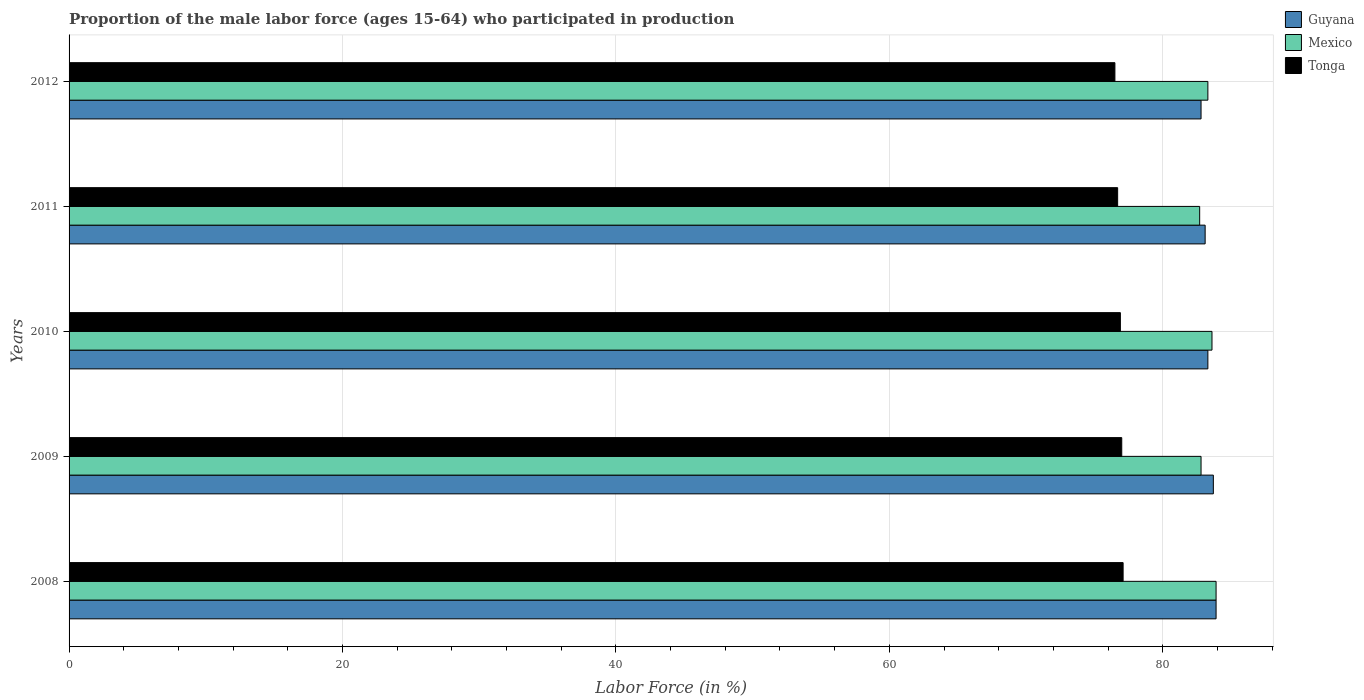How many different coloured bars are there?
Your answer should be compact. 3. How many groups of bars are there?
Provide a short and direct response. 5. Are the number of bars per tick equal to the number of legend labels?
Provide a short and direct response. Yes. Are the number of bars on each tick of the Y-axis equal?
Offer a terse response. Yes. How many bars are there on the 4th tick from the bottom?
Provide a succinct answer. 3. What is the label of the 5th group of bars from the top?
Your response must be concise. 2008. In how many cases, is the number of bars for a given year not equal to the number of legend labels?
Provide a succinct answer. 0. What is the proportion of the male labor force who participated in production in Tonga in 2010?
Offer a terse response. 76.9. Across all years, what is the maximum proportion of the male labor force who participated in production in Tonga?
Give a very brief answer. 77.1. Across all years, what is the minimum proportion of the male labor force who participated in production in Guyana?
Your answer should be very brief. 82.8. In which year was the proportion of the male labor force who participated in production in Mexico maximum?
Your answer should be compact. 2008. In which year was the proportion of the male labor force who participated in production in Tonga minimum?
Ensure brevity in your answer.  2012. What is the total proportion of the male labor force who participated in production in Tonga in the graph?
Give a very brief answer. 384.2. What is the difference between the proportion of the male labor force who participated in production in Mexico in 2011 and that in 2012?
Offer a very short reply. -0.6. What is the average proportion of the male labor force who participated in production in Mexico per year?
Make the answer very short. 83.26. In the year 2009, what is the difference between the proportion of the male labor force who participated in production in Mexico and proportion of the male labor force who participated in production in Guyana?
Ensure brevity in your answer.  -0.9. What is the ratio of the proportion of the male labor force who participated in production in Guyana in 2010 to that in 2011?
Offer a very short reply. 1. Is the difference between the proportion of the male labor force who participated in production in Mexico in 2009 and 2011 greater than the difference between the proportion of the male labor force who participated in production in Guyana in 2009 and 2011?
Your response must be concise. No. What is the difference between the highest and the second highest proportion of the male labor force who participated in production in Tonga?
Ensure brevity in your answer.  0.1. What is the difference between the highest and the lowest proportion of the male labor force who participated in production in Mexico?
Ensure brevity in your answer.  1.2. In how many years, is the proportion of the male labor force who participated in production in Mexico greater than the average proportion of the male labor force who participated in production in Mexico taken over all years?
Offer a very short reply. 3. What does the 3rd bar from the top in 2012 represents?
Ensure brevity in your answer.  Guyana. What does the 1st bar from the bottom in 2012 represents?
Give a very brief answer. Guyana. Are all the bars in the graph horizontal?
Your answer should be compact. Yes. How many years are there in the graph?
Provide a succinct answer. 5. Are the values on the major ticks of X-axis written in scientific E-notation?
Your answer should be compact. No. Does the graph contain any zero values?
Provide a succinct answer. No. Does the graph contain grids?
Your response must be concise. Yes. How many legend labels are there?
Offer a very short reply. 3. How are the legend labels stacked?
Offer a terse response. Vertical. What is the title of the graph?
Offer a very short reply. Proportion of the male labor force (ages 15-64) who participated in production. What is the label or title of the X-axis?
Offer a terse response. Labor Force (in %). What is the label or title of the Y-axis?
Keep it short and to the point. Years. What is the Labor Force (in %) in Guyana in 2008?
Ensure brevity in your answer.  83.9. What is the Labor Force (in %) in Mexico in 2008?
Offer a very short reply. 83.9. What is the Labor Force (in %) of Tonga in 2008?
Your response must be concise. 77.1. What is the Labor Force (in %) in Guyana in 2009?
Give a very brief answer. 83.7. What is the Labor Force (in %) of Mexico in 2009?
Keep it short and to the point. 82.8. What is the Labor Force (in %) of Tonga in 2009?
Keep it short and to the point. 77. What is the Labor Force (in %) of Guyana in 2010?
Keep it short and to the point. 83.3. What is the Labor Force (in %) in Mexico in 2010?
Keep it short and to the point. 83.6. What is the Labor Force (in %) of Tonga in 2010?
Keep it short and to the point. 76.9. What is the Labor Force (in %) in Guyana in 2011?
Offer a very short reply. 83.1. What is the Labor Force (in %) of Mexico in 2011?
Give a very brief answer. 82.7. What is the Labor Force (in %) in Tonga in 2011?
Ensure brevity in your answer.  76.7. What is the Labor Force (in %) in Guyana in 2012?
Your response must be concise. 82.8. What is the Labor Force (in %) of Mexico in 2012?
Offer a terse response. 83.3. What is the Labor Force (in %) in Tonga in 2012?
Give a very brief answer. 76.5. Across all years, what is the maximum Labor Force (in %) of Guyana?
Offer a terse response. 83.9. Across all years, what is the maximum Labor Force (in %) in Mexico?
Give a very brief answer. 83.9. Across all years, what is the maximum Labor Force (in %) of Tonga?
Provide a short and direct response. 77.1. Across all years, what is the minimum Labor Force (in %) in Guyana?
Offer a very short reply. 82.8. Across all years, what is the minimum Labor Force (in %) of Mexico?
Make the answer very short. 82.7. Across all years, what is the minimum Labor Force (in %) in Tonga?
Offer a very short reply. 76.5. What is the total Labor Force (in %) of Guyana in the graph?
Give a very brief answer. 416.8. What is the total Labor Force (in %) in Mexico in the graph?
Give a very brief answer. 416.3. What is the total Labor Force (in %) of Tonga in the graph?
Provide a succinct answer. 384.2. What is the difference between the Labor Force (in %) of Guyana in 2008 and that in 2009?
Keep it short and to the point. 0.2. What is the difference between the Labor Force (in %) in Tonga in 2008 and that in 2009?
Your answer should be very brief. 0.1. What is the difference between the Labor Force (in %) of Guyana in 2008 and that in 2010?
Offer a very short reply. 0.6. What is the difference between the Labor Force (in %) of Mexico in 2008 and that in 2011?
Offer a very short reply. 1.2. What is the difference between the Labor Force (in %) in Tonga in 2008 and that in 2012?
Your answer should be compact. 0.6. What is the difference between the Labor Force (in %) of Tonga in 2009 and that in 2010?
Make the answer very short. 0.1. What is the difference between the Labor Force (in %) in Guyana in 2009 and that in 2011?
Give a very brief answer. 0.6. What is the difference between the Labor Force (in %) of Mexico in 2009 and that in 2011?
Your answer should be compact. 0.1. What is the difference between the Labor Force (in %) of Guyana in 2009 and that in 2012?
Provide a short and direct response. 0.9. What is the difference between the Labor Force (in %) of Mexico in 2010 and that in 2011?
Your answer should be very brief. 0.9. What is the difference between the Labor Force (in %) of Tonga in 2010 and that in 2011?
Provide a short and direct response. 0.2. What is the difference between the Labor Force (in %) in Tonga in 2010 and that in 2012?
Keep it short and to the point. 0.4. What is the difference between the Labor Force (in %) of Guyana in 2011 and that in 2012?
Provide a short and direct response. 0.3. What is the difference between the Labor Force (in %) in Mexico in 2011 and that in 2012?
Keep it short and to the point. -0.6. What is the difference between the Labor Force (in %) of Guyana in 2008 and the Labor Force (in %) of Tonga in 2009?
Provide a short and direct response. 6.9. What is the difference between the Labor Force (in %) in Mexico in 2008 and the Labor Force (in %) in Tonga in 2010?
Provide a short and direct response. 7. What is the difference between the Labor Force (in %) of Guyana in 2008 and the Labor Force (in %) of Tonga in 2011?
Your answer should be compact. 7.2. What is the difference between the Labor Force (in %) in Mexico in 2008 and the Labor Force (in %) in Tonga in 2011?
Give a very brief answer. 7.2. What is the difference between the Labor Force (in %) in Guyana in 2008 and the Labor Force (in %) in Mexico in 2012?
Provide a short and direct response. 0.6. What is the difference between the Labor Force (in %) in Guyana in 2008 and the Labor Force (in %) in Tonga in 2012?
Offer a terse response. 7.4. What is the difference between the Labor Force (in %) of Guyana in 2009 and the Labor Force (in %) of Tonga in 2010?
Make the answer very short. 6.8. What is the difference between the Labor Force (in %) in Mexico in 2009 and the Labor Force (in %) in Tonga in 2010?
Provide a short and direct response. 5.9. What is the difference between the Labor Force (in %) of Mexico in 2009 and the Labor Force (in %) of Tonga in 2011?
Your answer should be very brief. 6.1. What is the difference between the Labor Force (in %) of Guyana in 2009 and the Labor Force (in %) of Mexico in 2012?
Offer a very short reply. 0.4. What is the difference between the Labor Force (in %) of Guyana in 2010 and the Labor Force (in %) of Mexico in 2011?
Make the answer very short. 0.6. What is the difference between the Labor Force (in %) of Guyana in 2010 and the Labor Force (in %) of Tonga in 2011?
Offer a very short reply. 6.6. What is the difference between the Labor Force (in %) in Guyana in 2010 and the Labor Force (in %) in Mexico in 2012?
Keep it short and to the point. 0. What is the difference between the Labor Force (in %) in Guyana in 2011 and the Labor Force (in %) in Mexico in 2012?
Give a very brief answer. -0.2. What is the difference between the Labor Force (in %) in Mexico in 2011 and the Labor Force (in %) in Tonga in 2012?
Keep it short and to the point. 6.2. What is the average Labor Force (in %) in Guyana per year?
Ensure brevity in your answer.  83.36. What is the average Labor Force (in %) of Mexico per year?
Provide a succinct answer. 83.26. What is the average Labor Force (in %) of Tonga per year?
Your answer should be very brief. 76.84. In the year 2008, what is the difference between the Labor Force (in %) of Guyana and Labor Force (in %) of Mexico?
Make the answer very short. 0. In the year 2008, what is the difference between the Labor Force (in %) of Guyana and Labor Force (in %) of Tonga?
Your answer should be compact. 6.8. In the year 2008, what is the difference between the Labor Force (in %) of Mexico and Labor Force (in %) of Tonga?
Provide a succinct answer. 6.8. In the year 2010, what is the difference between the Labor Force (in %) of Guyana and Labor Force (in %) of Mexico?
Give a very brief answer. -0.3. In the year 2010, what is the difference between the Labor Force (in %) of Guyana and Labor Force (in %) of Tonga?
Provide a succinct answer. 6.4. In the year 2010, what is the difference between the Labor Force (in %) in Mexico and Labor Force (in %) in Tonga?
Provide a short and direct response. 6.7. In the year 2011, what is the difference between the Labor Force (in %) of Guyana and Labor Force (in %) of Mexico?
Your answer should be very brief. 0.4. In the year 2011, what is the difference between the Labor Force (in %) of Mexico and Labor Force (in %) of Tonga?
Give a very brief answer. 6. In the year 2012, what is the difference between the Labor Force (in %) in Guyana and Labor Force (in %) in Mexico?
Your answer should be compact. -0.5. In the year 2012, what is the difference between the Labor Force (in %) in Guyana and Labor Force (in %) in Tonga?
Provide a succinct answer. 6.3. What is the ratio of the Labor Force (in %) of Guyana in 2008 to that in 2009?
Keep it short and to the point. 1. What is the ratio of the Labor Force (in %) in Mexico in 2008 to that in 2009?
Keep it short and to the point. 1.01. What is the ratio of the Labor Force (in %) in Tonga in 2008 to that in 2009?
Your response must be concise. 1. What is the ratio of the Labor Force (in %) of Mexico in 2008 to that in 2010?
Your answer should be very brief. 1. What is the ratio of the Labor Force (in %) in Guyana in 2008 to that in 2011?
Provide a succinct answer. 1.01. What is the ratio of the Labor Force (in %) of Mexico in 2008 to that in 2011?
Your answer should be very brief. 1.01. What is the ratio of the Labor Force (in %) of Tonga in 2008 to that in 2011?
Offer a very short reply. 1.01. What is the ratio of the Labor Force (in %) of Guyana in 2008 to that in 2012?
Provide a succinct answer. 1.01. What is the ratio of the Labor Force (in %) of Mexico in 2008 to that in 2012?
Offer a very short reply. 1.01. What is the ratio of the Labor Force (in %) in Mexico in 2009 to that in 2010?
Provide a succinct answer. 0.99. What is the ratio of the Labor Force (in %) in Tonga in 2009 to that in 2011?
Your response must be concise. 1. What is the ratio of the Labor Force (in %) in Guyana in 2009 to that in 2012?
Offer a terse response. 1.01. What is the ratio of the Labor Force (in %) in Mexico in 2009 to that in 2012?
Keep it short and to the point. 0.99. What is the ratio of the Labor Force (in %) in Mexico in 2010 to that in 2011?
Provide a succinct answer. 1.01. What is the ratio of the Labor Force (in %) of Mexico in 2011 to that in 2012?
Your answer should be compact. 0.99. What is the difference between the highest and the second highest Labor Force (in %) of Mexico?
Keep it short and to the point. 0.3. What is the difference between the highest and the lowest Labor Force (in %) of Guyana?
Give a very brief answer. 1.1. 